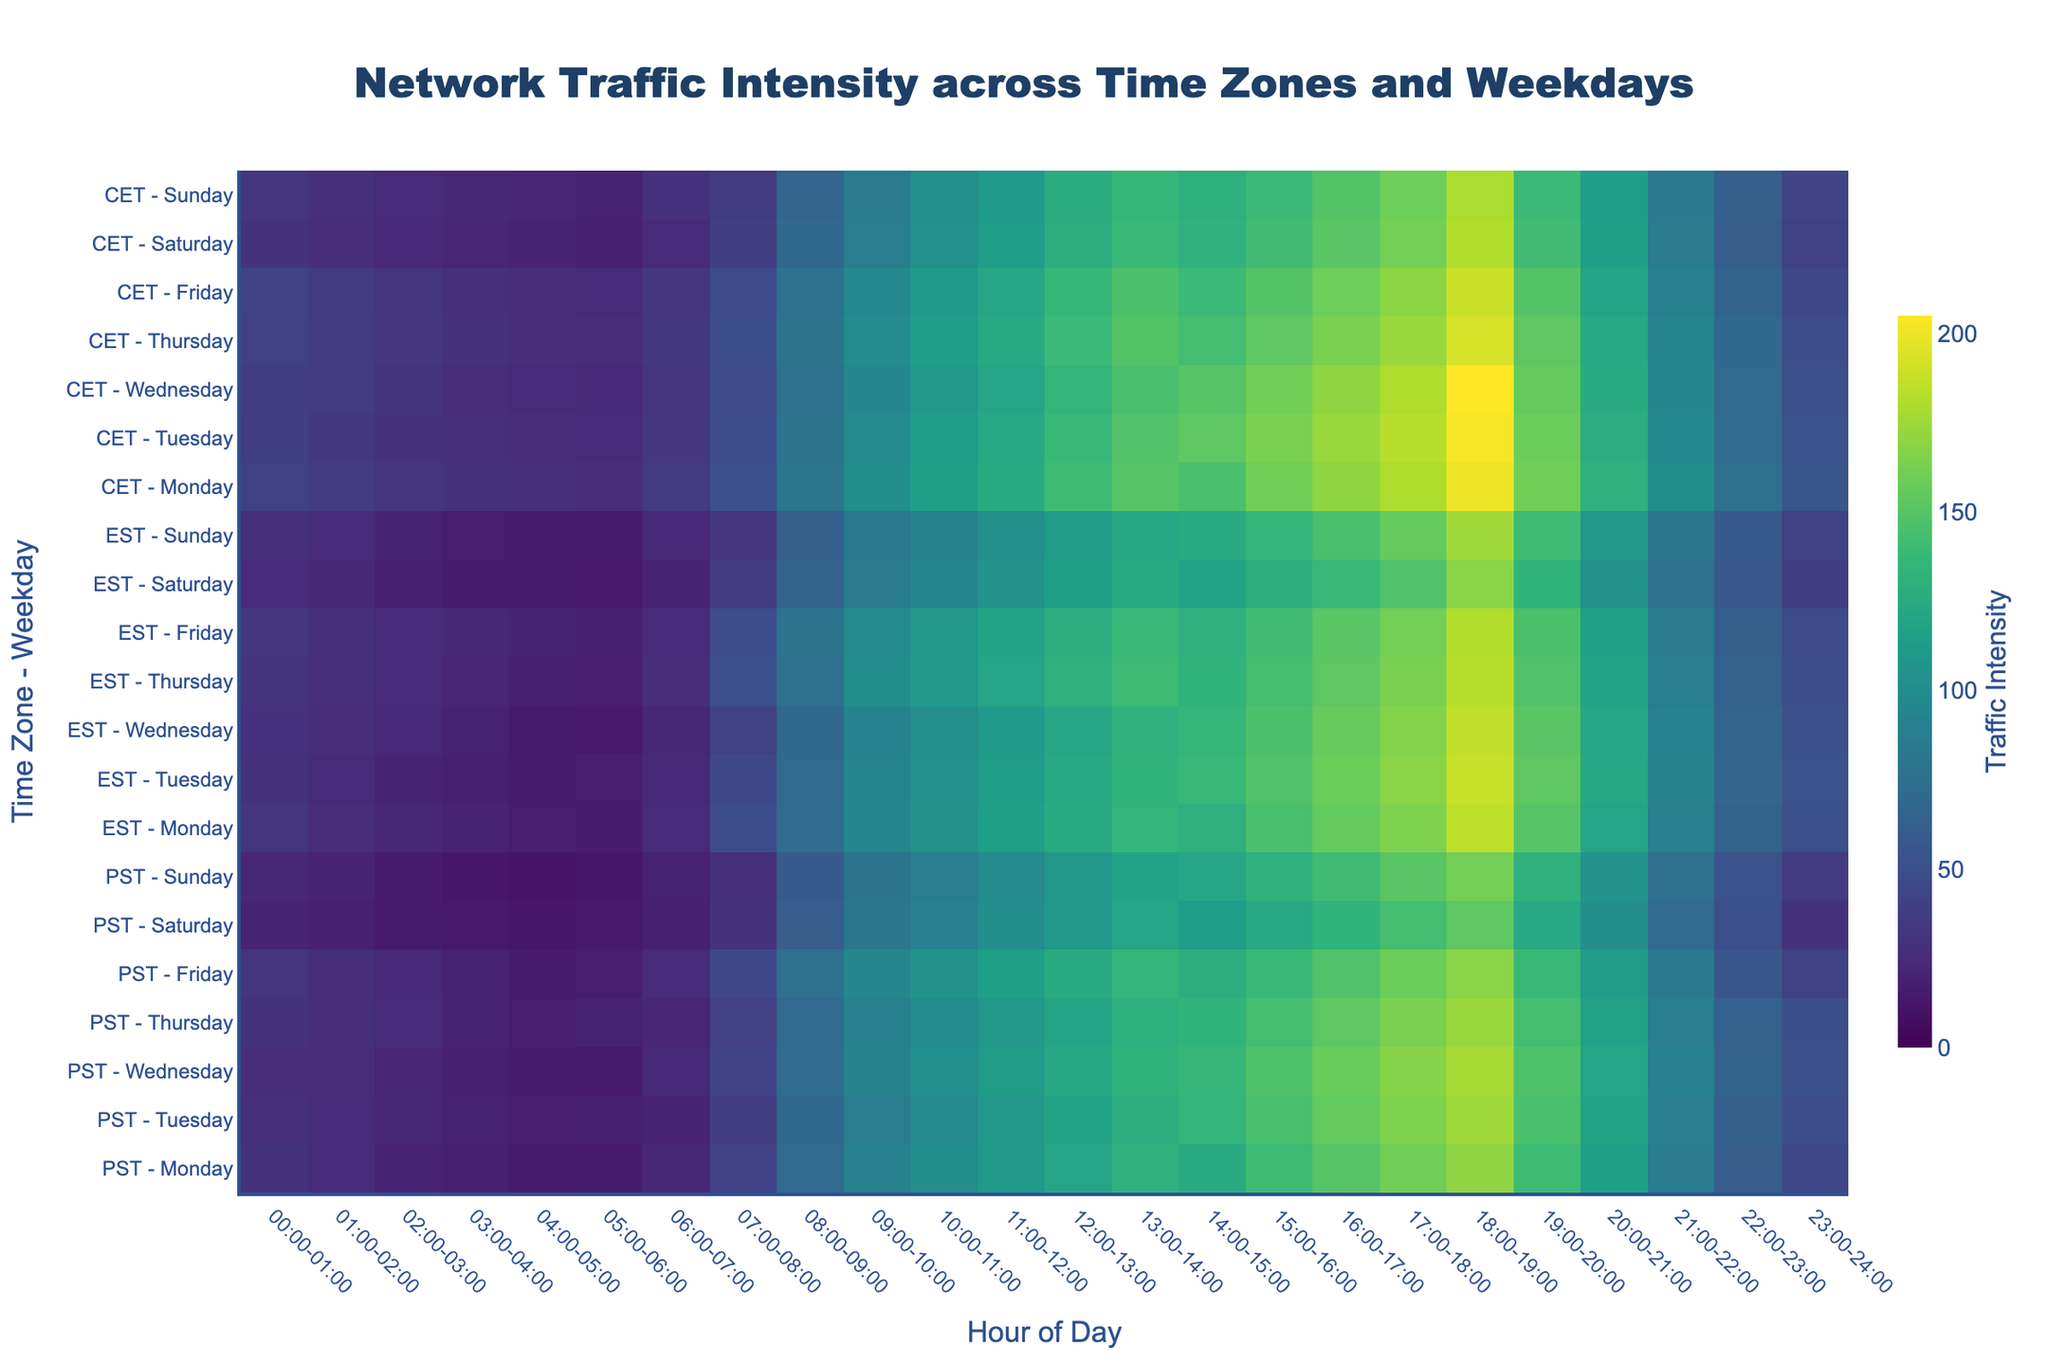What is the title of the heatmap? The title appears at the top of the heatmap and provides a summary of what the data visualizes. The title here reads 'Network Traffic Intensity across Time Zones and Weekdays'.
Answer: Network Traffic Intensity across Time Zones and Weekdays Which time zone and weekday combination shows the highest traffic intensity at 14:00-15:00? Look for the highest value in the column representing 14:00-15:00 across all entries. The highest value belongs to CET - Tuesday at 153.
Answer: CET - Tuesday What is the average traffic intensity for PST on Monday from 08:00-09:00 to 12:00-13:00? Calculate the average by summing the values at 08:00-09:00, 09:00-10:00, 10:00-11:00, 11:00-12:00, and 12:00-13:00, which are (70 + 90 + 100 + 110 + 120 = 490) and divide by 5.
Answer: 98 Which time zone generally has higher traffic intensities, PST or EST? Compare the overall intensity patterns by visually inspecting the color gradients for PST and EST throughout the heatmap. EST generally shows higher traffic intensities.
Answer: EST During which hours does traffic intensity peak in the CET time zone on Fridays? Identify the hour with the darkest shade (highest value) on the CET - Friday row. The peak traffic intensity for CET - Friday occurs at 13:00-14:00 with a value of 146.
Answer: 13:00-14:00 What is the difference in traffic at 22:00-23:00 on Sundays between PST and EST? For PST - Sunday, the value at 22:00-23:00 is 52, and for EST - Sunday, it is 58. Calculate the difference: 58 - 52 = 6.
Answer: 6 Which weekday in CET has the least traffic intensity at 05:00-06:00? Look at the values for 05:00-06:00 across all weekdays in the CET time zone. Sunday has the least traffic intensity with a value of 19.
Answer: Sunday How does the traffic trend for PST change from Monday to Friday at 00:00-01:00? Compare the traffic values from Monday to Friday at 00:00-01:00 for PST. The values are (30, 28, 27, 30, 32), showing a slight increase towards Friday.
Answer: The trend is generally increasing What is the total traffic intensity for CET on Wednesday from 00:00-06:00? Sum the traffic values for CET - Wednesday from 00:00-01:00 to 05:00-06:00 (37 + 35 + 31 + 27 + 25 + 23 = 178).
Answer: 178 